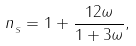Convert formula to latex. <formula><loc_0><loc_0><loc_500><loc_500>n _ { _ { S } } = 1 + \frac { 1 2 \omega } { 1 + 3 \omega } ,</formula> 